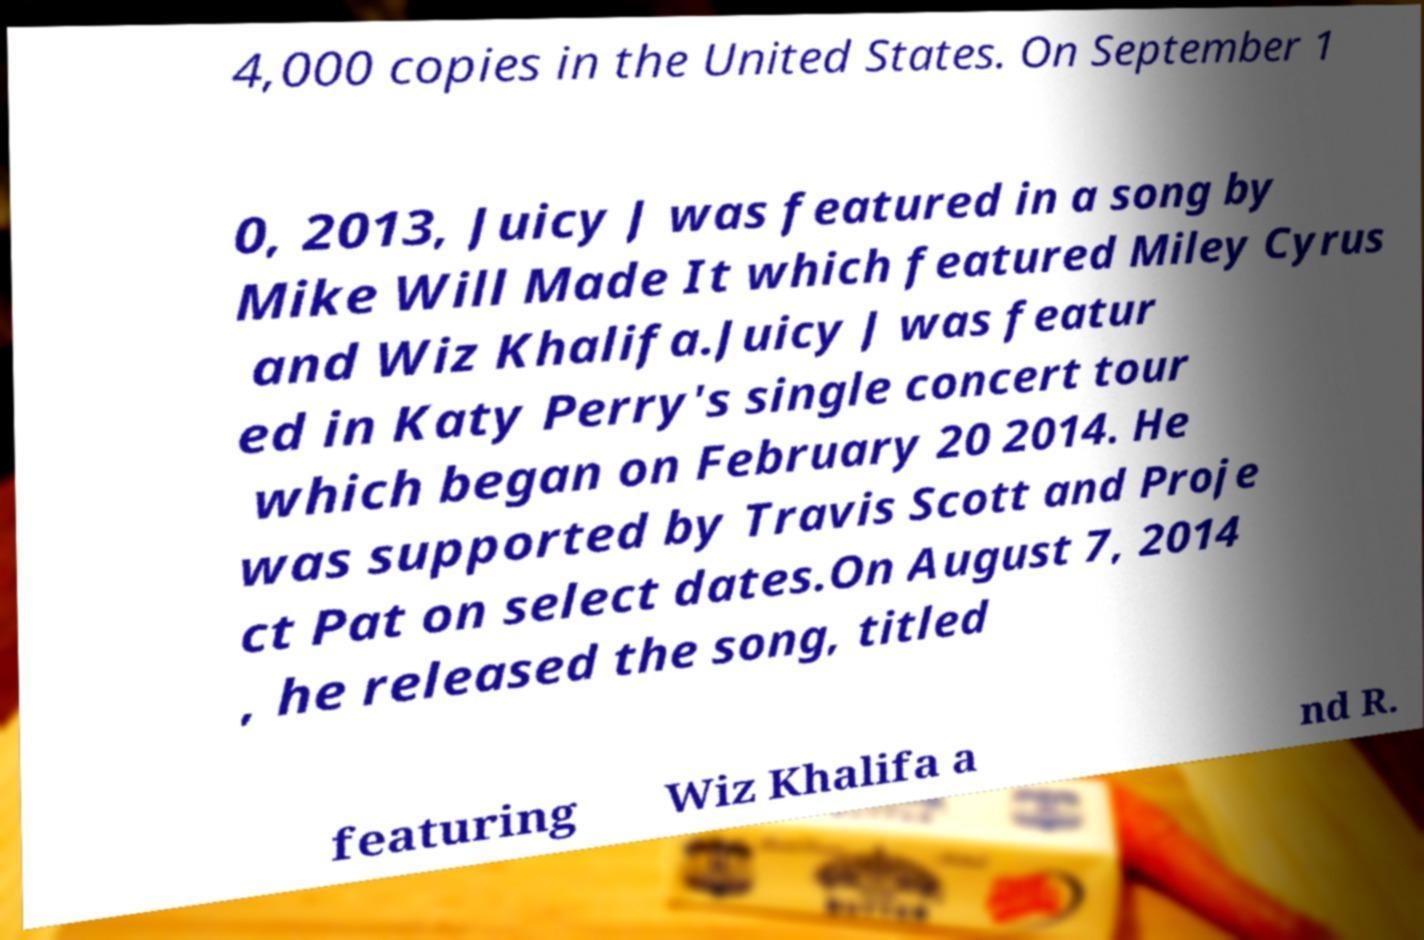Can you accurately transcribe the text from the provided image for me? 4,000 copies in the United States. On September 1 0, 2013, Juicy J was featured in a song by Mike Will Made It which featured Miley Cyrus and Wiz Khalifa.Juicy J was featur ed in Katy Perry's single concert tour which began on February 20 2014. He was supported by Travis Scott and Proje ct Pat on select dates.On August 7, 2014 , he released the song, titled featuring Wiz Khalifa a nd R. 